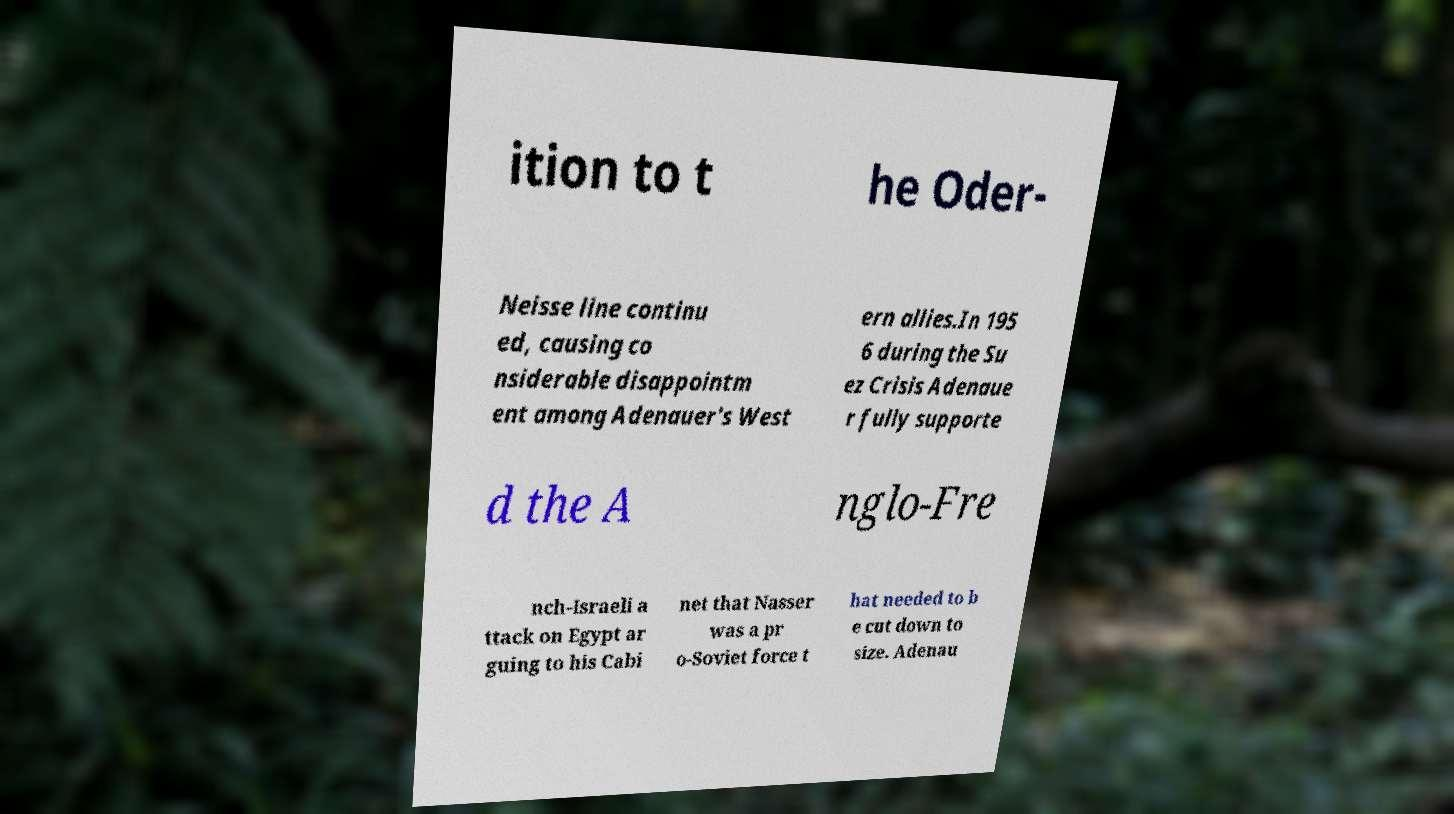Can you read and provide the text displayed in the image?This photo seems to have some interesting text. Can you extract and type it out for me? ition to t he Oder- Neisse line continu ed, causing co nsiderable disappointm ent among Adenauer's West ern allies.In 195 6 during the Su ez Crisis Adenaue r fully supporte d the A nglo-Fre nch-Israeli a ttack on Egypt ar guing to his Cabi net that Nasser was a pr o-Soviet force t hat needed to b e cut down to size. Adenau 